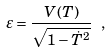Convert formula to latex. <formula><loc_0><loc_0><loc_500><loc_500>\varepsilon = { \frac { V ( T ) } { \sqrt { 1 - \dot { T } ^ { 2 } } } } \ ,</formula> 